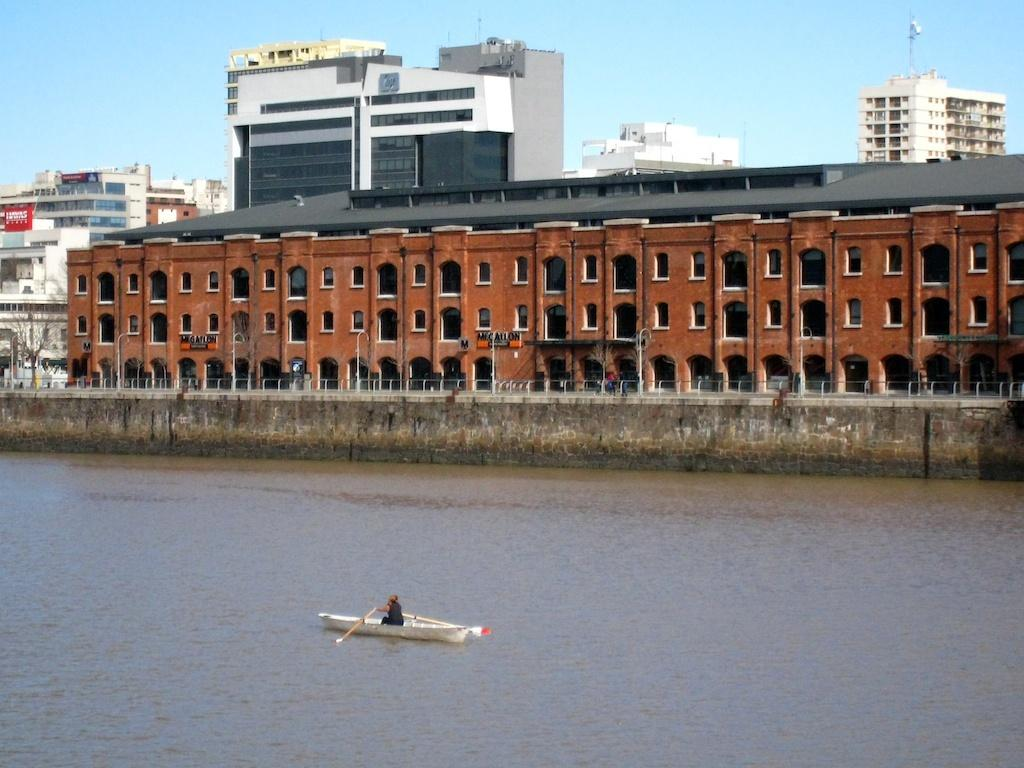What type of structures can be seen in the image? There are buildings in the image. What else is present in the image besides the buildings? There are poles and a dry tree visible in the image. What is the condition of the sky in the image? The sky is visible in the image. What is the person in the image holding? The person is holding a paddle in the image. Where is the person located in the image? The person is in a boat in the image. What is the boat resting on? The boat is on the water surface in the image. Where is the cushion placed in the image? There is no cushion present in the image. What type of business is being conducted in the image? There is no indication of any business activity in the image. 